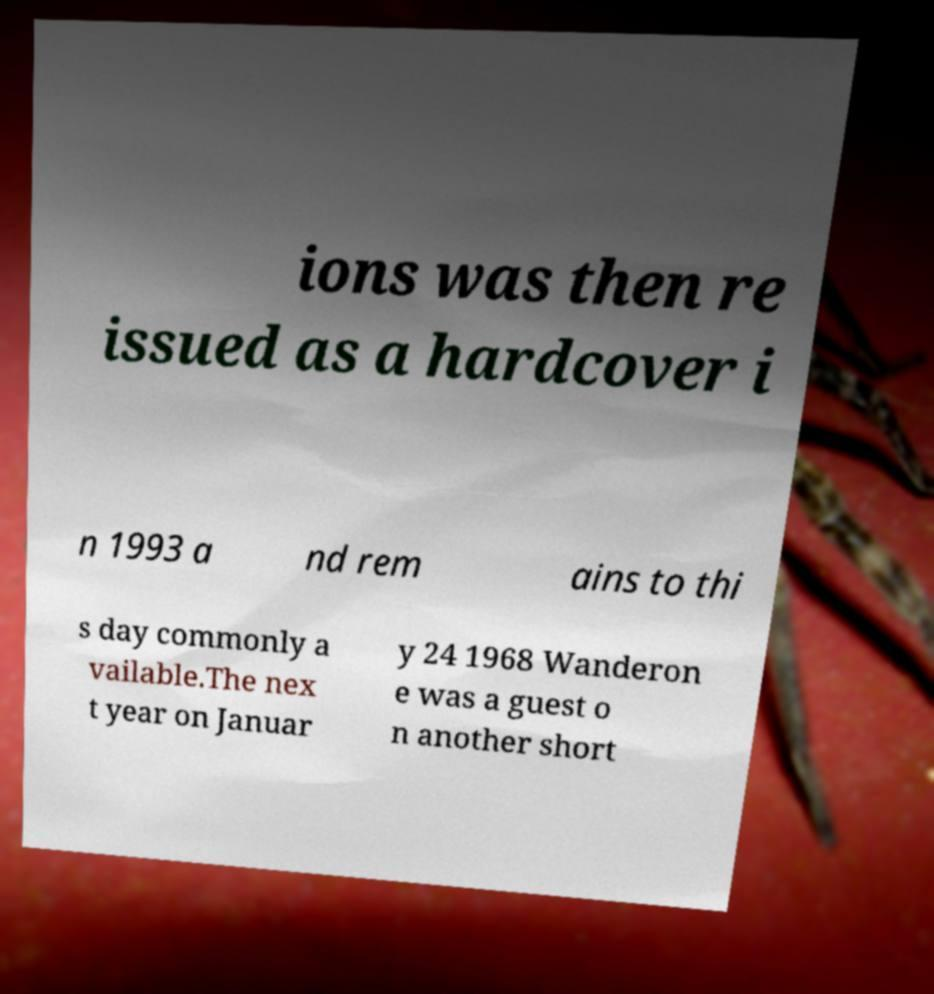Could you assist in decoding the text presented in this image and type it out clearly? ions was then re issued as a hardcover i n 1993 a nd rem ains to thi s day commonly a vailable.The nex t year on Januar y 24 1968 Wanderon e was a guest o n another short 